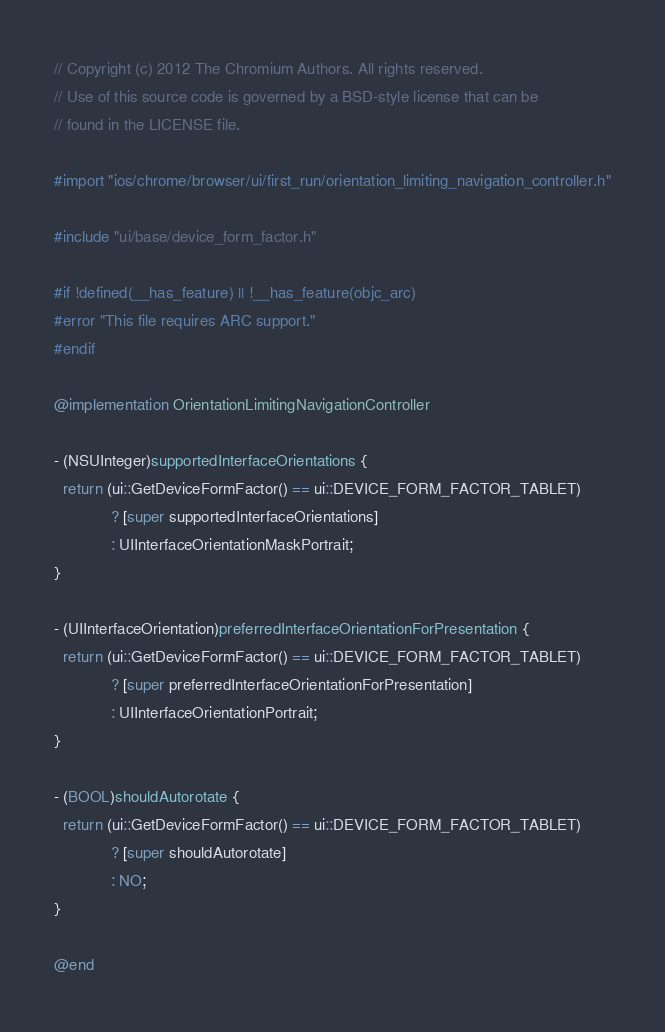<code> <loc_0><loc_0><loc_500><loc_500><_ObjectiveC_>// Copyright (c) 2012 The Chromium Authors. All rights reserved.
// Use of this source code is governed by a BSD-style license that can be
// found in the LICENSE file.

#import "ios/chrome/browser/ui/first_run/orientation_limiting_navigation_controller.h"

#include "ui/base/device_form_factor.h"

#if !defined(__has_feature) || !__has_feature(objc_arc)
#error "This file requires ARC support."
#endif

@implementation OrientationLimitingNavigationController

- (NSUInteger)supportedInterfaceOrientations {
  return (ui::GetDeviceFormFactor() == ui::DEVICE_FORM_FACTOR_TABLET)
             ? [super supportedInterfaceOrientations]
             : UIInterfaceOrientationMaskPortrait;
}

- (UIInterfaceOrientation)preferredInterfaceOrientationForPresentation {
  return (ui::GetDeviceFormFactor() == ui::DEVICE_FORM_FACTOR_TABLET)
             ? [super preferredInterfaceOrientationForPresentation]
             : UIInterfaceOrientationPortrait;
}

- (BOOL)shouldAutorotate {
  return (ui::GetDeviceFormFactor() == ui::DEVICE_FORM_FACTOR_TABLET)
             ? [super shouldAutorotate]
             : NO;
}

@end
</code> 